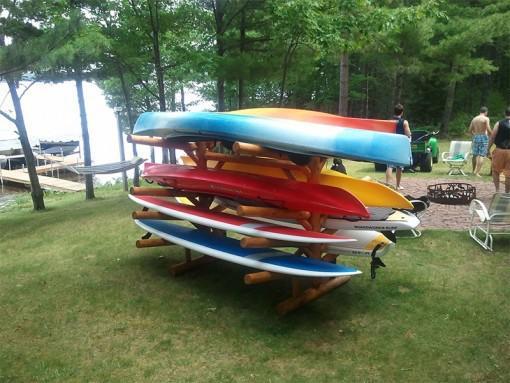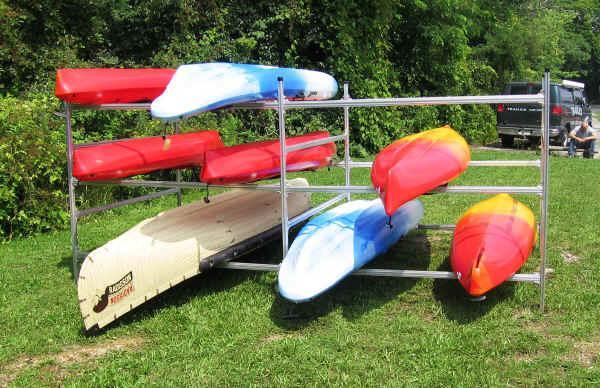The first image is the image on the left, the second image is the image on the right. Evaluate the accuracy of this statement regarding the images: "At least two of the canoes are green.". Is it true? Answer yes or no. No. The first image is the image on the left, the second image is the image on the right. Evaluate the accuracy of this statement regarding the images: "3 canoes are stacked on a platform". Is it true? Answer yes or no. No. 